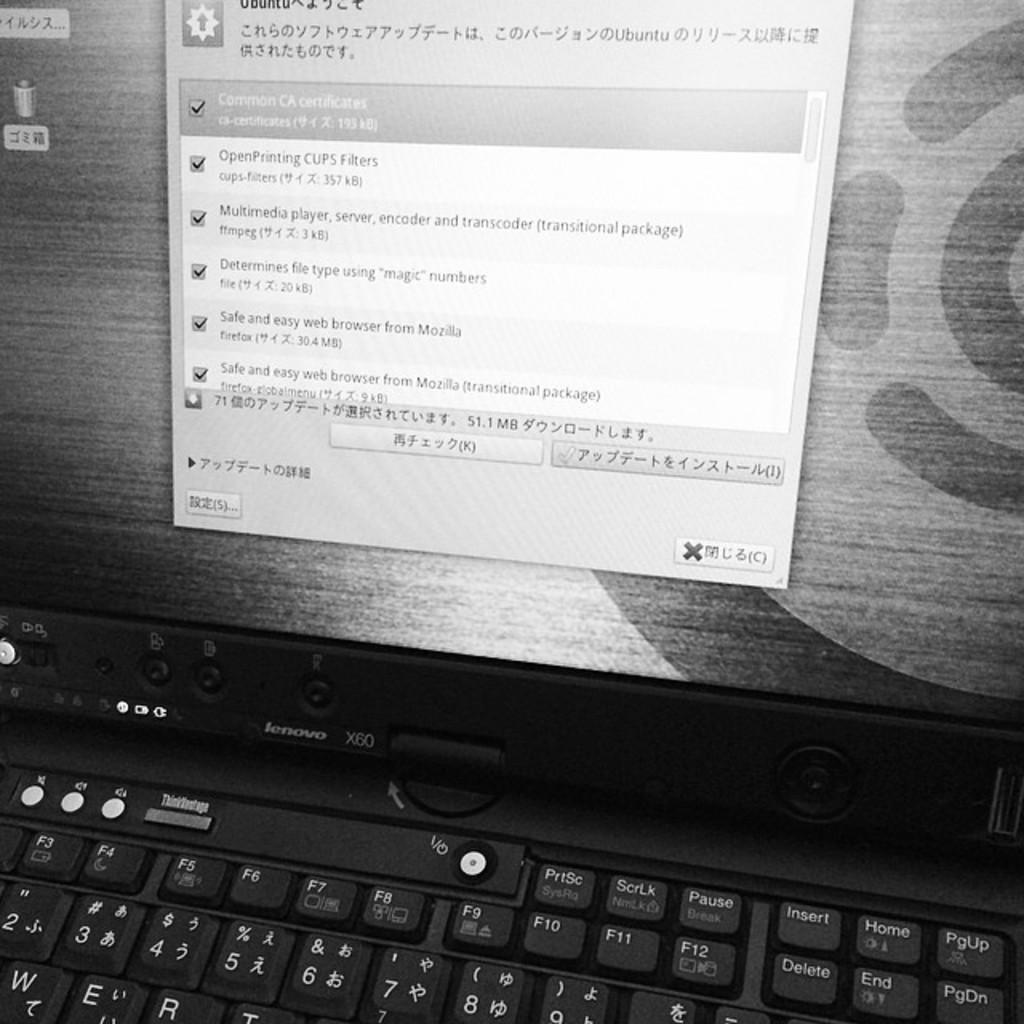<image>
Relay a brief, clear account of the picture shown. A laptop screen with asian text on it including "Safe and easy web browser from Mozilla." 